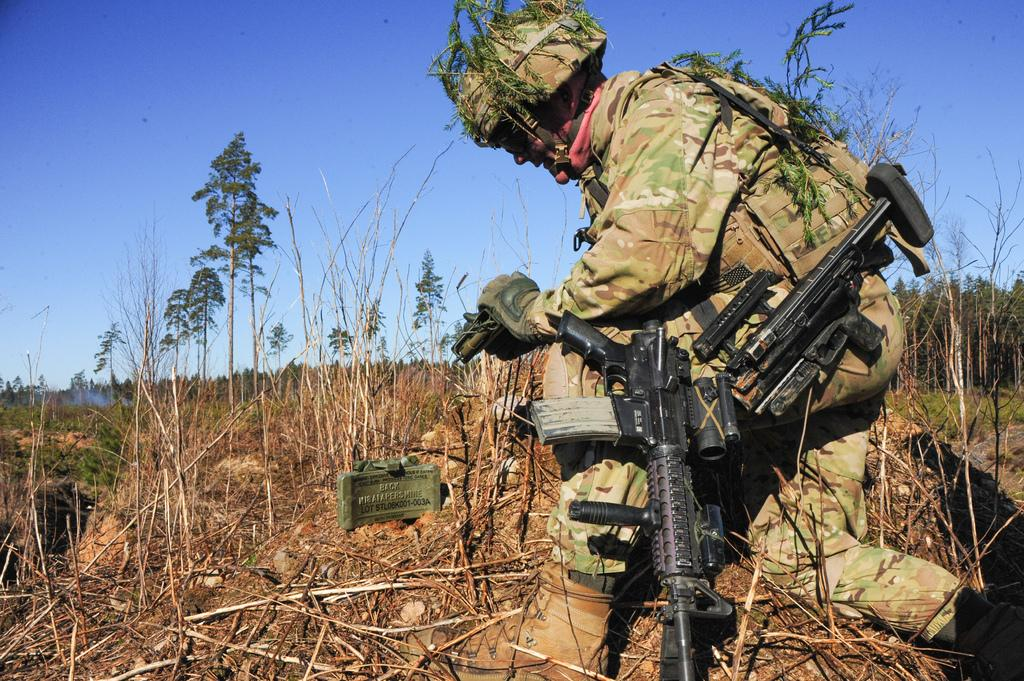Who is present in the image? There is a man in the image. What is the man holding in the image? The man is carrying guns. What protective gear is the man wearing? The man is wearing a helmet. What position is the man in the image? The man is squatting on the land. What type of vegetation can be seen in the image? There are plants in the image. What can be seen in the background of the image? The sky is visible in the background of the image. What type of silver object can be seen in the man's hand in the image? There is no silver object visible in the man's hand in the image; he is carrying guns. Can you tell me how many apples are on the ground in the image? There are no apples present in the image; it features a man carrying guns and squatting on the land. 